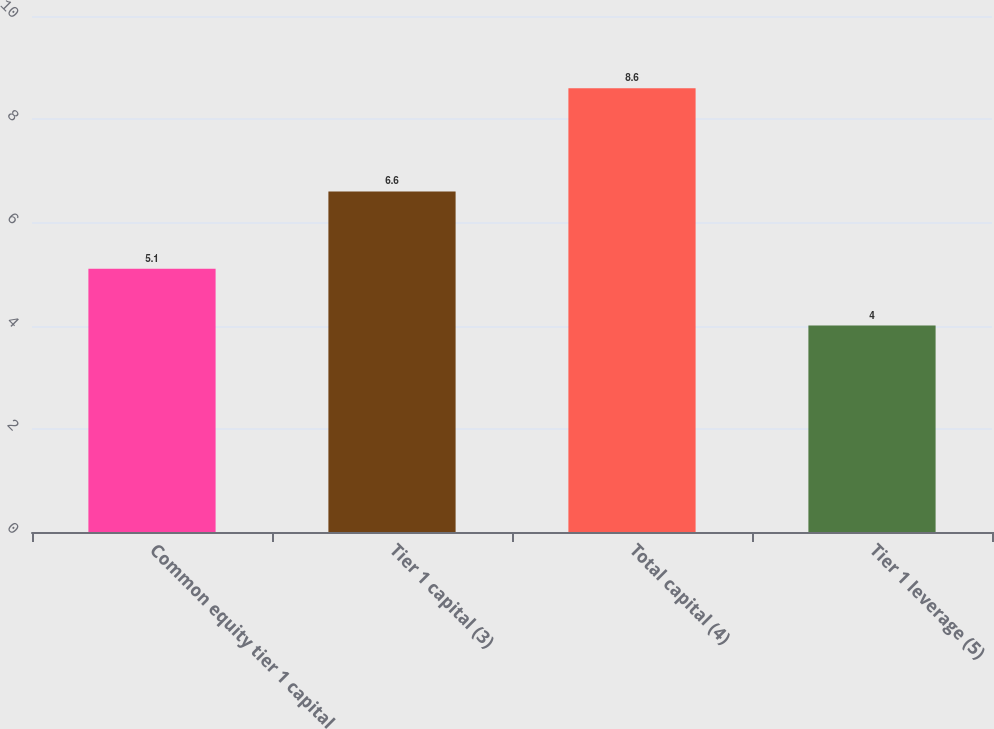Convert chart. <chart><loc_0><loc_0><loc_500><loc_500><bar_chart><fcel>Common equity tier 1 capital<fcel>Tier 1 capital (3)<fcel>Total capital (4)<fcel>Tier 1 leverage (5)<nl><fcel>5.1<fcel>6.6<fcel>8.6<fcel>4<nl></chart> 